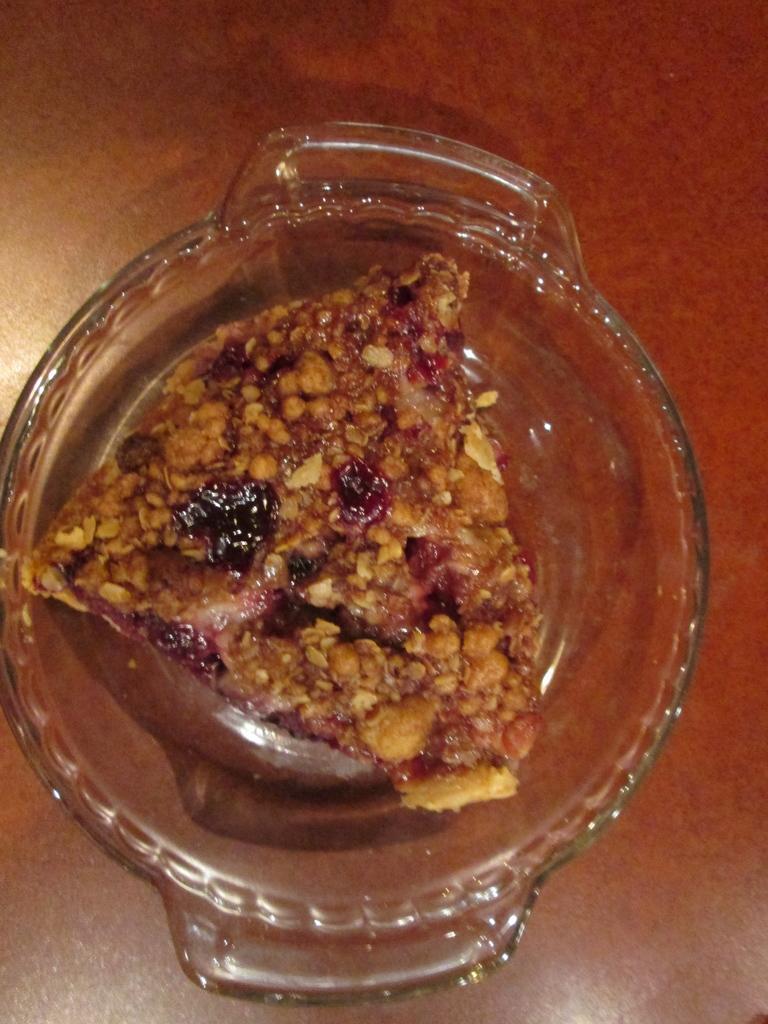Could you give a brief overview of what you see in this image? In this picture I can see food in the glass bowl and looks like a table in the background. 